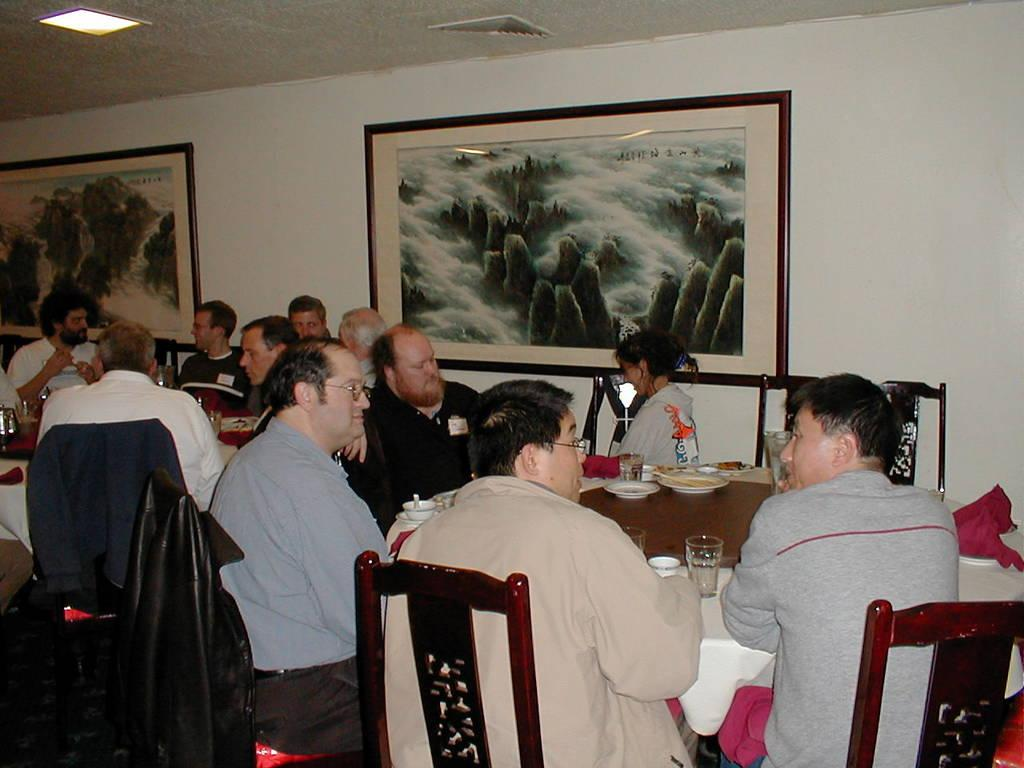What are the people in the image doing? There is a group of people sitting on chairs in the image. What objects can be seen on the table? There is a glass, a cup, a plate, and a spoon on the table in the image. Is there any decoration or artwork visible in the image? Yes, there is a frame on the wall in the image. What type of cannon is being used by the people sitting on chairs in the image? There is no cannon present in the image; it features a group of people sitting on chairs. How many stitches are visible on the frame in the image? The frame in the image does not have any visible stitches, as it is likely a piece of artwork or decoration. 